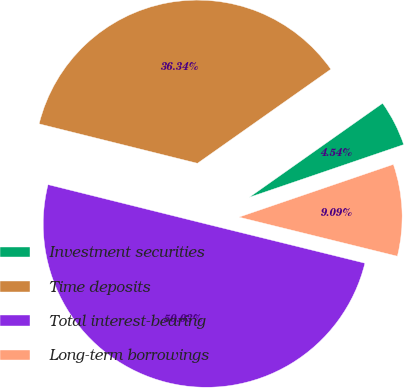<chart> <loc_0><loc_0><loc_500><loc_500><pie_chart><fcel>Investment securities<fcel>Time deposits<fcel>Total interest-bearing<fcel>Long-term borrowings<nl><fcel>4.54%<fcel>36.34%<fcel>50.04%<fcel>9.09%<nl></chart> 